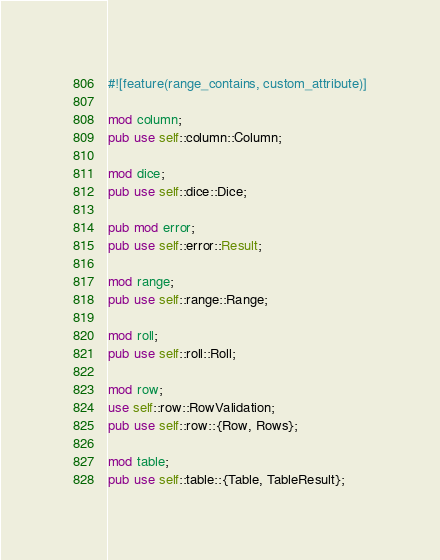<code> <loc_0><loc_0><loc_500><loc_500><_Rust_>#![feature(range_contains, custom_attribute)]

mod column;
pub use self::column::Column;

mod dice;
pub use self::dice::Dice;

pub mod error;
pub use self::error::Result;

mod range;
pub use self::range::Range;

mod roll;
pub use self::roll::Roll;

mod row;
use self::row::RowValidation;
pub use self::row::{Row, Rows};

mod table;
pub use self::table::{Table, TableResult};
</code> 